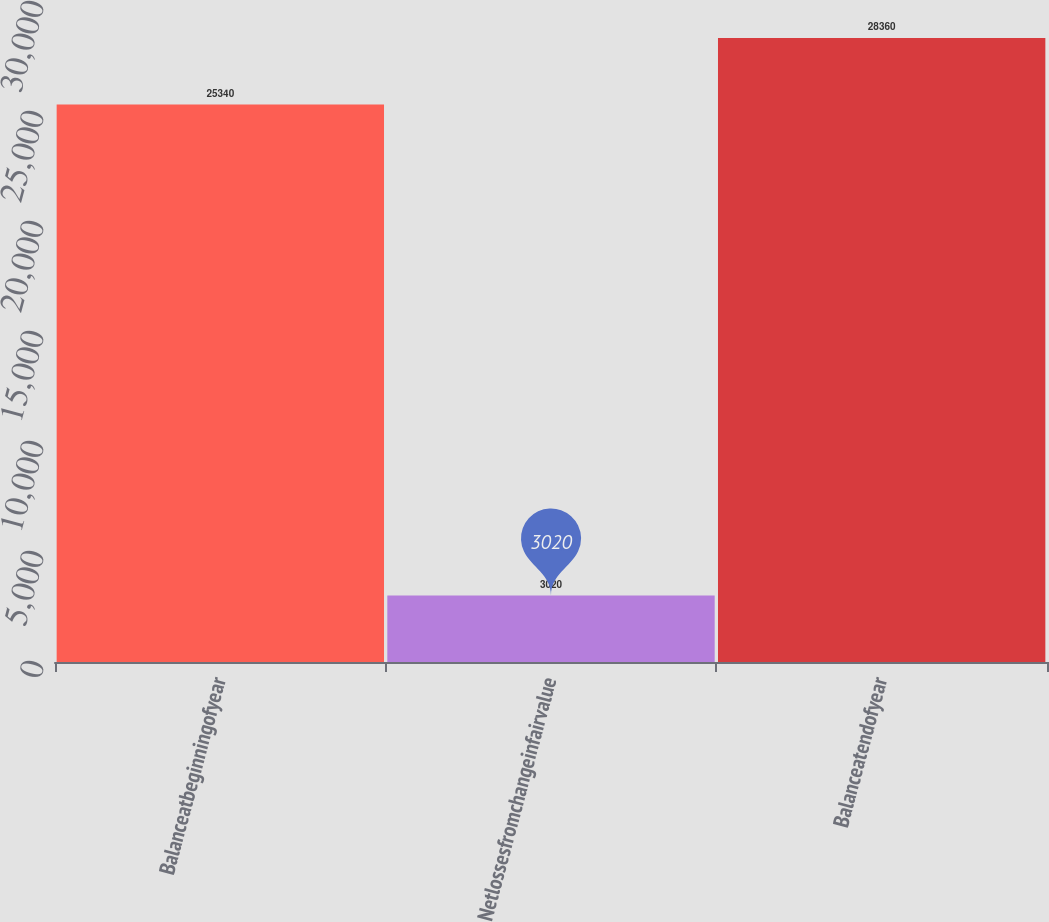Convert chart. <chart><loc_0><loc_0><loc_500><loc_500><bar_chart><fcel>Balanceatbeginningofyear<fcel>Netlossesfromchangeinfairvalue<fcel>Balanceatendofyear<nl><fcel>25340<fcel>3020<fcel>28360<nl></chart> 